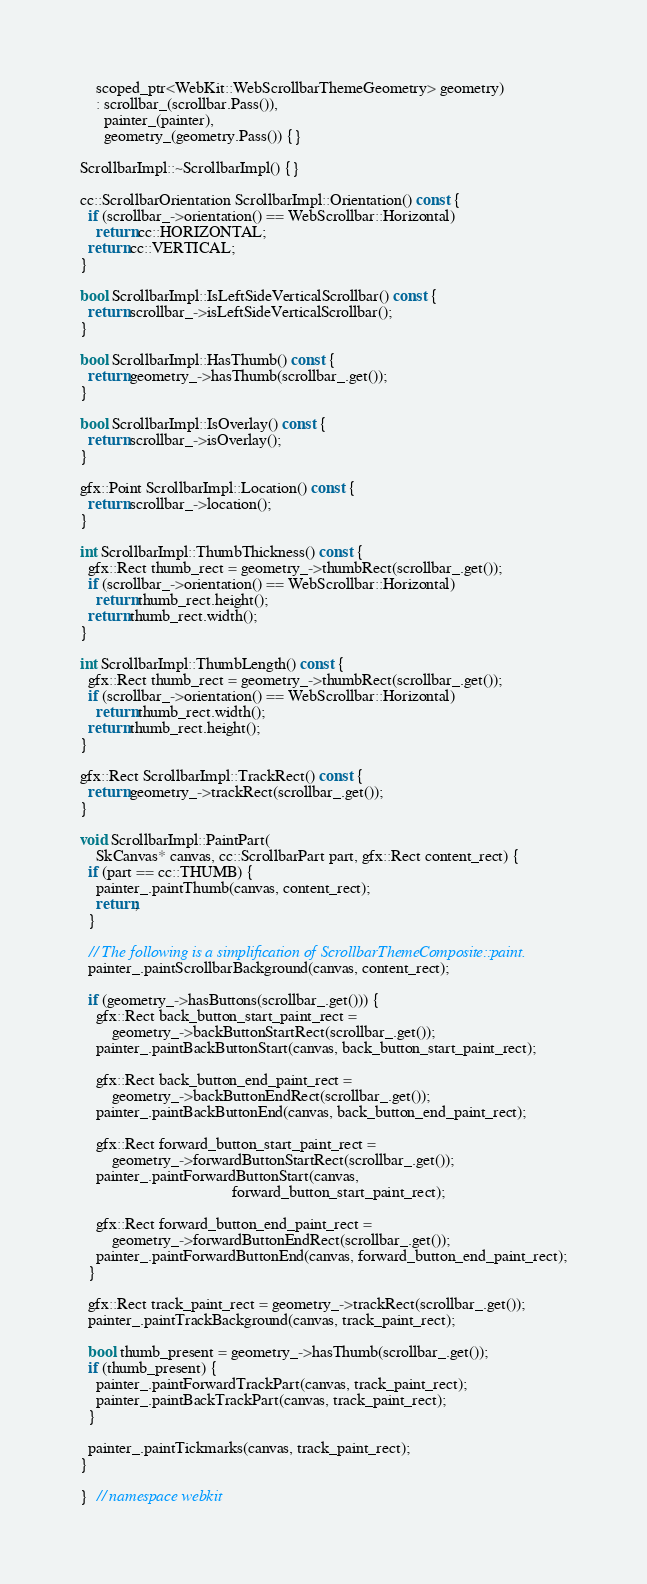<code> <loc_0><loc_0><loc_500><loc_500><_C++_>    scoped_ptr<WebKit::WebScrollbarThemeGeometry> geometry)
    : scrollbar_(scrollbar.Pass()),
      painter_(painter),
      geometry_(geometry.Pass()) {}

ScrollbarImpl::~ScrollbarImpl() {}

cc::ScrollbarOrientation ScrollbarImpl::Orientation() const {
  if (scrollbar_->orientation() == WebScrollbar::Horizontal)
    return cc::HORIZONTAL;
  return cc::VERTICAL;
}

bool ScrollbarImpl::IsLeftSideVerticalScrollbar() const {
  return scrollbar_->isLeftSideVerticalScrollbar();
}

bool ScrollbarImpl::HasThumb() const {
  return geometry_->hasThumb(scrollbar_.get());
}

bool ScrollbarImpl::IsOverlay() const {
  return scrollbar_->isOverlay();
}

gfx::Point ScrollbarImpl::Location() const {
  return scrollbar_->location();
}

int ScrollbarImpl::ThumbThickness() const {
  gfx::Rect thumb_rect = geometry_->thumbRect(scrollbar_.get());
  if (scrollbar_->orientation() == WebScrollbar::Horizontal)
    return thumb_rect.height();
  return thumb_rect.width();
}

int ScrollbarImpl::ThumbLength() const {
  gfx::Rect thumb_rect = geometry_->thumbRect(scrollbar_.get());
  if (scrollbar_->orientation() == WebScrollbar::Horizontal)
    return thumb_rect.width();
  return thumb_rect.height();
}

gfx::Rect ScrollbarImpl::TrackRect() const {
  return geometry_->trackRect(scrollbar_.get());
}

void ScrollbarImpl::PaintPart(
    SkCanvas* canvas, cc::ScrollbarPart part, gfx::Rect content_rect) {
  if (part == cc::THUMB) {
    painter_.paintThumb(canvas, content_rect);
    return;
  }

  // The following is a simplification of ScrollbarThemeComposite::paint.
  painter_.paintScrollbarBackground(canvas, content_rect);

  if (geometry_->hasButtons(scrollbar_.get())) {
    gfx::Rect back_button_start_paint_rect =
        geometry_->backButtonStartRect(scrollbar_.get());
    painter_.paintBackButtonStart(canvas, back_button_start_paint_rect);

    gfx::Rect back_button_end_paint_rect =
        geometry_->backButtonEndRect(scrollbar_.get());
    painter_.paintBackButtonEnd(canvas, back_button_end_paint_rect);

    gfx::Rect forward_button_start_paint_rect =
        geometry_->forwardButtonStartRect(scrollbar_.get());
    painter_.paintForwardButtonStart(canvas,
                                      forward_button_start_paint_rect);

    gfx::Rect forward_button_end_paint_rect =
        geometry_->forwardButtonEndRect(scrollbar_.get());
    painter_.paintForwardButtonEnd(canvas, forward_button_end_paint_rect);
  }

  gfx::Rect track_paint_rect = geometry_->trackRect(scrollbar_.get());
  painter_.paintTrackBackground(canvas, track_paint_rect);

  bool thumb_present = geometry_->hasThumb(scrollbar_.get());
  if (thumb_present) {
    painter_.paintForwardTrackPart(canvas, track_paint_rect);
    painter_.paintBackTrackPart(canvas, track_paint_rect);
  }

  painter_.paintTickmarks(canvas, track_paint_rect);
}

}  // namespace webkit
</code> 